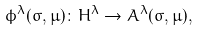<formula> <loc_0><loc_0><loc_500><loc_500>\phi ^ { \lambda } ( \sigma , \mu ) \colon H ^ { \lambda } \rightarrow A ^ { \lambda } ( \sigma , \mu ) ,</formula> 